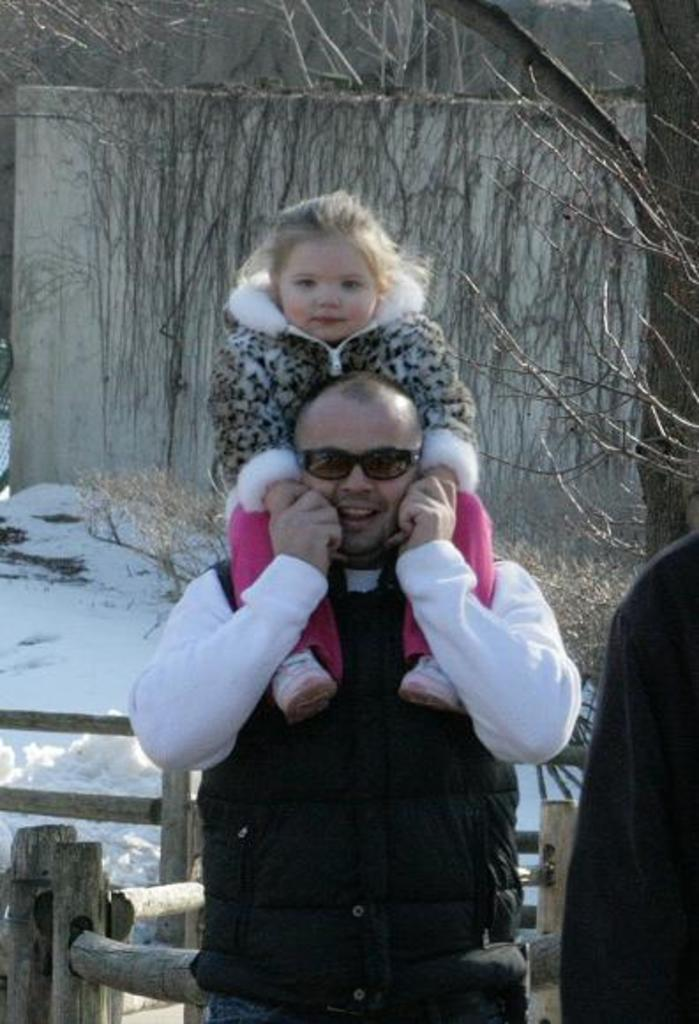How many people are in the front of the image? There are three persons in the front of the image. What are the persons holding in their hands? The persons are holding wooden sticks. What is the weather condition in the image? There is snow in the image, indicating a cold or wintery condition. What is the background of the image? There is a wall and a dry tree in the image. What color are the dresses worn by the persons in the front? The persons in the front are wearing black color dresses. What route are the tigers taking in the image? There are no tigers present in the image. What is the shocking event happening in the image? There is no shocking event depicted in the image; it features three persons holding wooden sticks in front of a wall and a dry tree. 